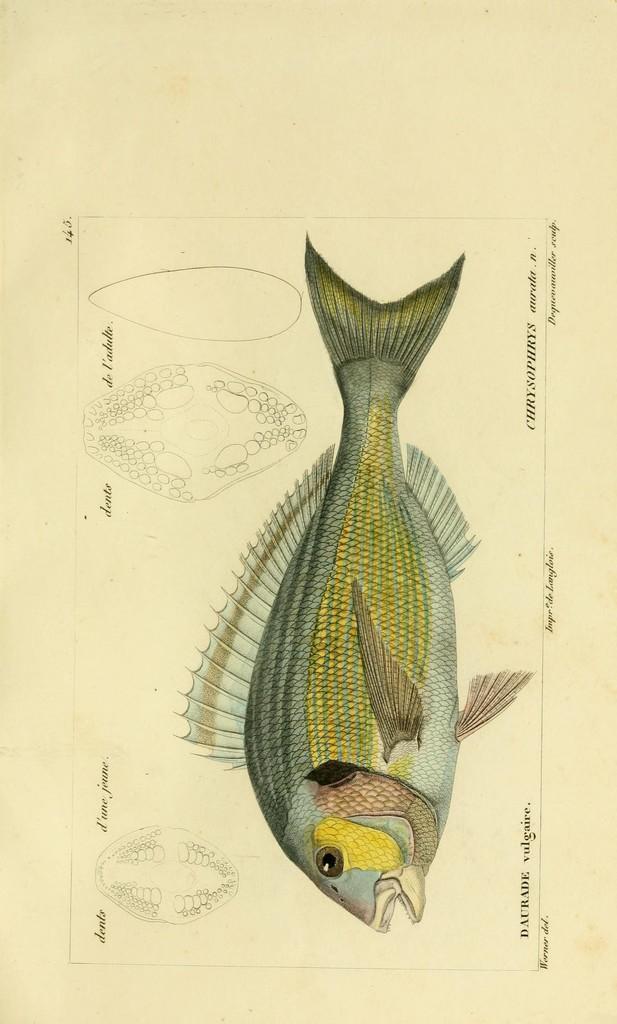Can you describe this image briefly? In this image I see the light brown color paper on which there is a diagram of a fish which is colorful and I see few sketches over here and I see few words written. 